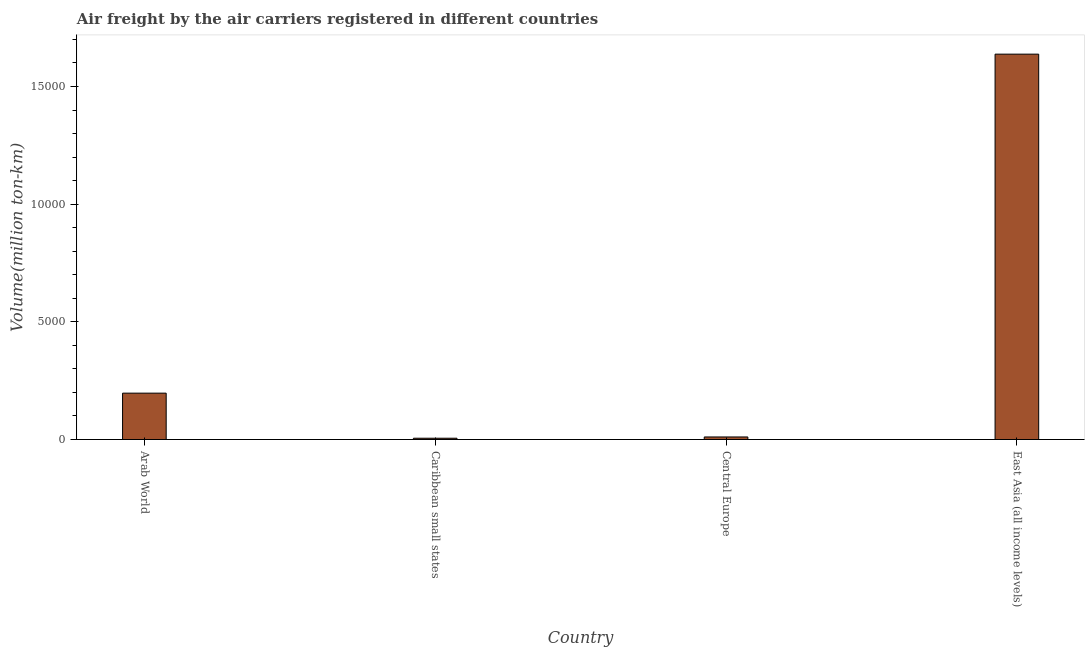Does the graph contain grids?
Provide a succinct answer. No. What is the title of the graph?
Provide a succinct answer. Air freight by the air carriers registered in different countries. What is the label or title of the Y-axis?
Offer a terse response. Volume(million ton-km). What is the air freight in Caribbean small states?
Offer a terse response. 55.1. Across all countries, what is the maximum air freight?
Offer a very short reply. 1.64e+04. Across all countries, what is the minimum air freight?
Your answer should be very brief. 55.1. In which country was the air freight maximum?
Ensure brevity in your answer.  East Asia (all income levels). In which country was the air freight minimum?
Make the answer very short. Caribbean small states. What is the sum of the air freight?
Your answer should be compact. 1.85e+04. What is the difference between the air freight in Caribbean small states and East Asia (all income levels)?
Your response must be concise. -1.63e+04. What is the average air freight per country?
Keep it short and to the point. 4627.27. What is the median air freight?
Offer a very short reply. 1039.65. What is the ratio of the air freight in Arab World to that in East Asia (all income levels)?
Ensure brevity in your answer.  0.12. Is the air freight in Arab World less than that in Caribbean small states?
Ensure brevity in your answer.  No. What is the difference between the highest and the second highest air freight?
Ensure brevity in your answer.  1.44e+04. Is the sum of the air freight in Caribbean small states and East Asia (all income levels) greater than the maximum air freight across all countries?
Keep it short and to the point. Yes. What is the difference between the highest and the lowest air freight?
Ensure brevity in your answer.  1.63e+04. Are all the bars in the graph horizontal?
Give a very brief answer. No. How many countries are there in the graph?
Provide a short and direct response. 4. What is the difference between two consecutive major ticks on the Y-axis?
Your answer should be very brief. 5000. What is the Volume(million ton-km) of Arab World?
Provide a short and direct response. 1970.6. What is the Volume(million ton-km) of Caribbean small states?
Make the answer very short. 55.1. What is the Volume(million ton-km) in Central Europe?
Make the answer very short. 108.7. What is the Volume(million ton-km) of East Asia (all income levels)?
Make the answer very short. 1.64e+04. What is the difference between the Volume(million ton-km) in Arab World and Caribbean small states?
Offer a terse response. 1915.5. What is the difference between the Volume(million ton-km) in Arab World and Central Europe?
Your response must be concise. 1861.9. What is the difference between the Volume(million ton-km) in Arab World and East Asia (all income levels)?
Your answer should be very brief. -1.44e+04. What is the difference between the Volume(million ton-km) in Caribbean small states and Central Europe?
Your answer should be compact. -53.6. What is the difference between the Volume(million ton-km) in Caribbean small states and East Asia (all income levels)?
Offer a very short reply. -1.63e+04. What is the difference between the Volume(million ton-km) in Central Europe and East Asia (all income levels)?
Your answer should be compact. -1.63e+04. What is the ratio of the Volume(million ton-km) in Arab World to that in Caribbean small states?
Provide a short and direct response. 35.76. What is the ratio of the Volume(million ton-km) in Arab World to that in Central Europe?
Offer a terse response. 18.13. What is the ratio of the Volume(million ton-km) in Arab World to that in East Asia (all income levels)?
Give a very brief answer. 0.12. What is the ratio of the Volume(million ton-km) in Caribbean small states to that in Central Europe?
Offer a very short reply. 0.51. What is the ratio of the Volume(million ton-km) in Caribbean small states to that in East Asia (all income levels)?
Provide a succinct answer. 0. What is the ratio of the Volume(million ton-km) in Central Europe to that in East Asia (all income levels)?
Provide a succinct answer. 0.01. 